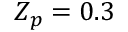<formula> <loc_0><loc_0><loc_500><loc_500>Z _ { p } = 0 . 3</formula> 